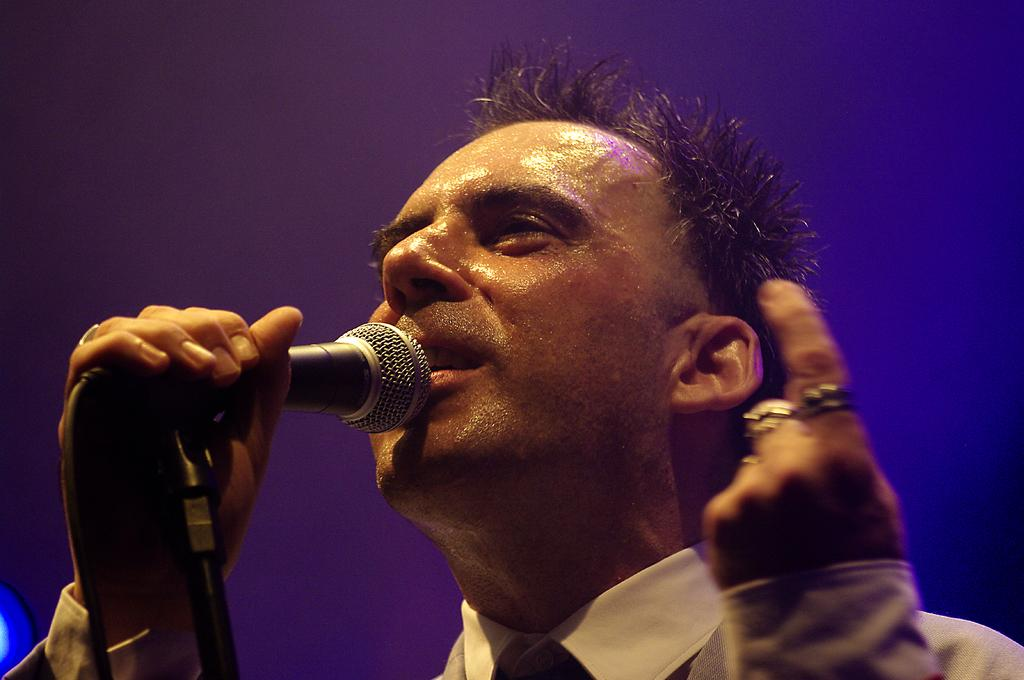What is the man in the image doing? The man is singing a song. What object is the man holding in the image? The man is holding a microphone. How is the microphone positioned in the image? The microphone is attached to a microphone stand. What can be observed about the background of the image? The background has a bluish color. Where are the kittens playing in the image? There are no kittens present in the image. What tool is the man using to fix the microphone stand in the image? The man is not using any tools to fix the microphone stand in the image; he is simply holding the microphone. 